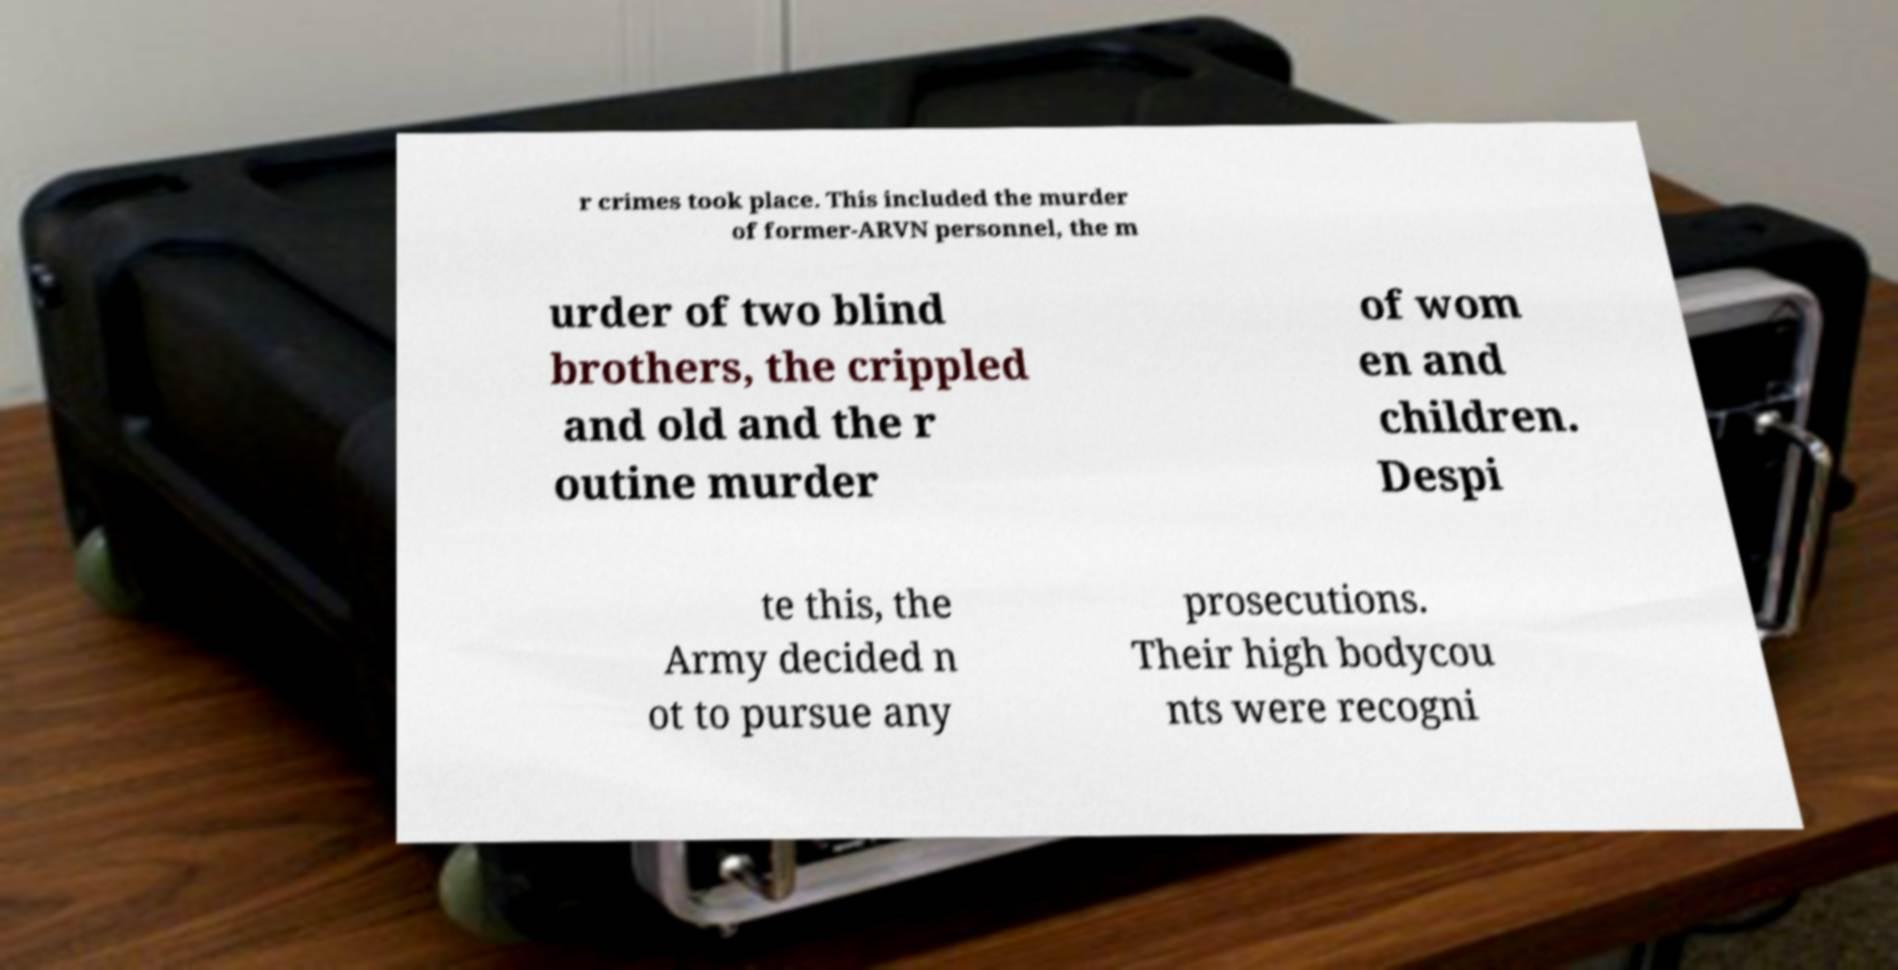There's text embedded in this image that I need extracted. Can you transcribe it verbatim? r crimes took place. This included the murder of former-ARVN personnel, the m urder of two blind brothers, the crippled and old and the r outine murder of wom en and children. Despi te this, the Army decided n ot to pursue any prosecutions. Their high bodycou nts were recogni 